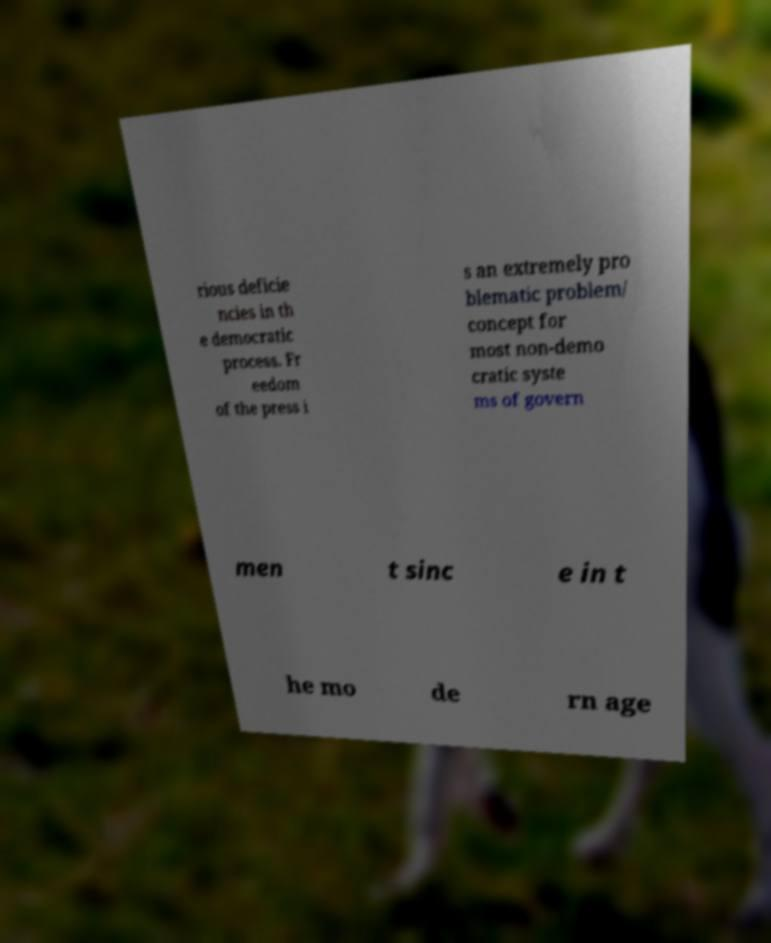Please identify and transcribe the text found in this image. rious deficie ncies in th e democratic process. Fr eedom of the press i s an extremely pro blematic problem/ concept for most non-demo cratic syste ms of govern men t sinc e in t he mo de rn age 